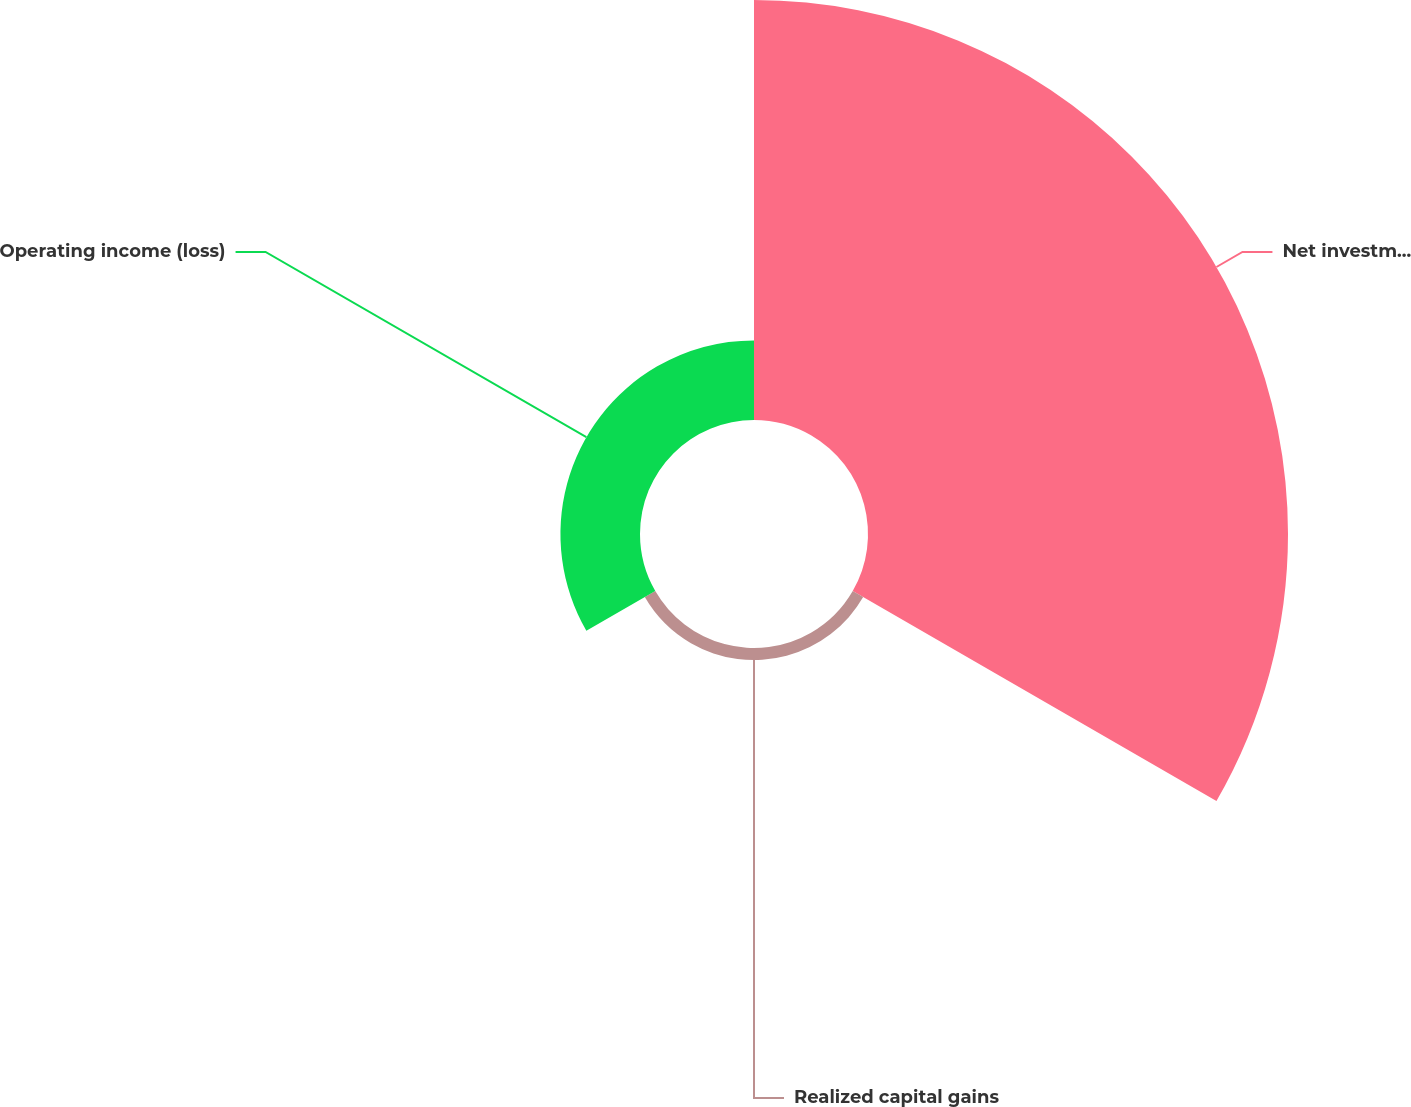<chart> <loc_0><loc_0><loc_500><loc_500><pie_chart><fcel>Net investment income<fcel>Realized capital gains<fcel>Operating income (loss)<nl><fcel>82.09%<fcel>2.36%<fcel>15.55%<nl></chart> 